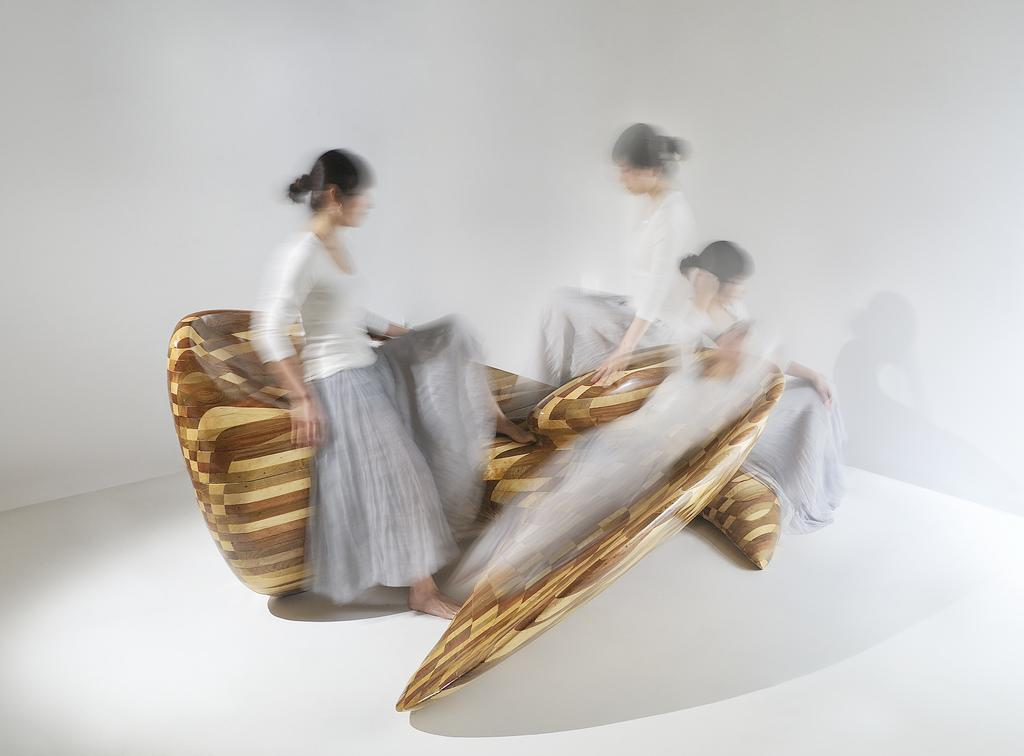What are the people in the image sitting on? The people in the image are sitting on wooden chairs. What can be seen beneath the people's feet in the image? The floor is visible in the image. What is located behind the people in the image? There is a wall in the background of the image. How many locks can be seen on the people's legs in the image? There are no locks visible on the people's legs in the image. What type of wound is present on the wall in the background? There is no wound present on the wall in the background; it is a solid structure. 